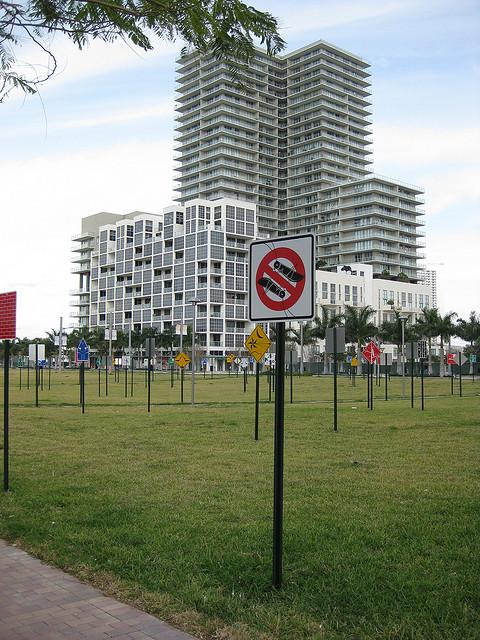Is there birds in the picture?
Concise answer only. No. Has this sign been graffitied?
Answer briefly. Yes. What is the purpose of this structure?
Give a very brief answer. Offices. Are there trees?
Keep it brief. Yes. Could it have rained recently?
Give a very brief answer. Yes. Does this look like a school building?
Quick response, please. No. Is there more than one sign on the grass?
Write a very short answer. Yes. Is this one building?
Concise answer only. Yes. 